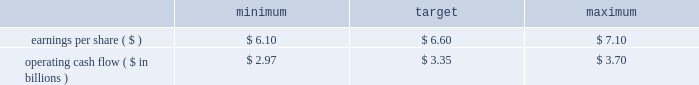The target awards for the other named executive officers were set as follows : joseph f .
Domino , ceo - entergy texas ( 50% ( 50 % ) ) ; hugh t .
Mcdonald , ceo - entergy arkansas ( 50% ( 50 % ) ) ; haley fisackerly , ceo - entergy mississippi ( 40% ( 40 % ) ) ; william m .
Mohl ( 60% ( 60 % ) ) , ceo - entergy gulf states and entergy louisiana ; charles l .
Rice , jr .
( 40% ( 40 % ) ) , ceo - entergy new orleans and theodore h .
Bunting , jr .
- principal accounting officer - the subsidiaries ( 60% ( 60 % ) ) .
The target awards for the named executive officers ( other than entergy named executive officers ) were set by their respective supervisors ( subject to ultimate approval of entergy 2019s chief executive officer ) who allocated a potential incentive pool established by the personnel committee among various of their direct and indirect reports .
In setting the target awards , the supervisor took into account considerations similar to those used by the personnel committee in setting the target awards for entergy 2019s named executive officers .
Target awards are set based on an executive officer 2019s current position and executive management level within the entergy organization .
Executive management levels at entergy range from level 1 thorough level 4 .
Mr .
Denault and mr .
Taylor hold positions in level 2 whereas mr .
Bunting and mr .
Mohl hold positions in level 3 and mr .
Domino , mr .
Fisackerly , mr .
Mcdonald and mr .
Rice hold positions in level 4 .
Accordingly , their respective incentive targets differ one from another based on the external market data developed by the committee 2019s independent compensation consultant and the other factors noted above .
In december 2010 , the committee determined the executive incentive plan targets to be used for purposes of establishing annual bonuses for 2011 .
The committee 2019s determination of the target levels was made after full board review of management 2019s 2011 financial plan for entergy corporation , upon recommendation of the finance committee , and after the committee 2019s determination that the established targets aligned with entergy corporation 2019s anticipated 2011 financial performance as reflected in the financial plan .
The targets established to measure management performance against as reported results were: .
Operating cash flow ( $ in billions ) in january 2012 , after reviewing earnings per share and operating cash flow results against the performance objectives in the above table , the committee determined that entergy corporation had exceeded as reported earnings per share target of $ 6.60 by $ 0.95 in 2011 while falling short of the operating cash flow goal of $ 3.35 billion by $ 221 million in 2011 .
In accordance with the terms of the annual incentive plan , in january 2012 , the personnel committee certified the 2012 entergy achievement multiplier at 128% ( 128 % ) of target .
Under the terms of the management effectiveness program , the entergy achievement multiplier is automatically increased by 25 percent for the members of the office of the chief executive if the pre- established underlying performance goals established by the personnel committee are satisfied at the end of the performance period , subject to the personnel committee's discretion to adjust the automatic multiplier downward or eliminate it altogether .
In accordance with section 162 ( m ) of the internal revenue code , the multiplier which entergy refers to as the management effectiveness factor is intended to provide the committee a mechanism to take into consideration specific achievement factors relating to the overall performance of entergy corporation .
In january 2012 , the committee eliminated the management effectiveness factor with respect to the 2011 incentive awards , reflecting the personnel committee's determination that the entergy achievement multiplier , in and of itself without the management effectiveness factor , was consistent with the performance levels achieved by management .
The annual incentive awards for the named executive officers ( other than mr .
Leonard , mr .
Denault and mr .
Taylor ) are awarded from an incentive pool approved by the committee .
From this pool , each named executive officer 2019s supervisor determines the annual incentive payment based on the entergy achievement multiplier .
The supervisor has the discretion to increase or decrease the multiple used to determine an incentive award based on individual and business unit performance .
The incentive awards are subject to the ultimate approval of entergy 2019s chief executive officer. .
What was the percent by which entergy corporation exceeded the reported earnings per share target in 2011? 
Computations: (0.95 / 6.60)
Answer: 0.14394. 